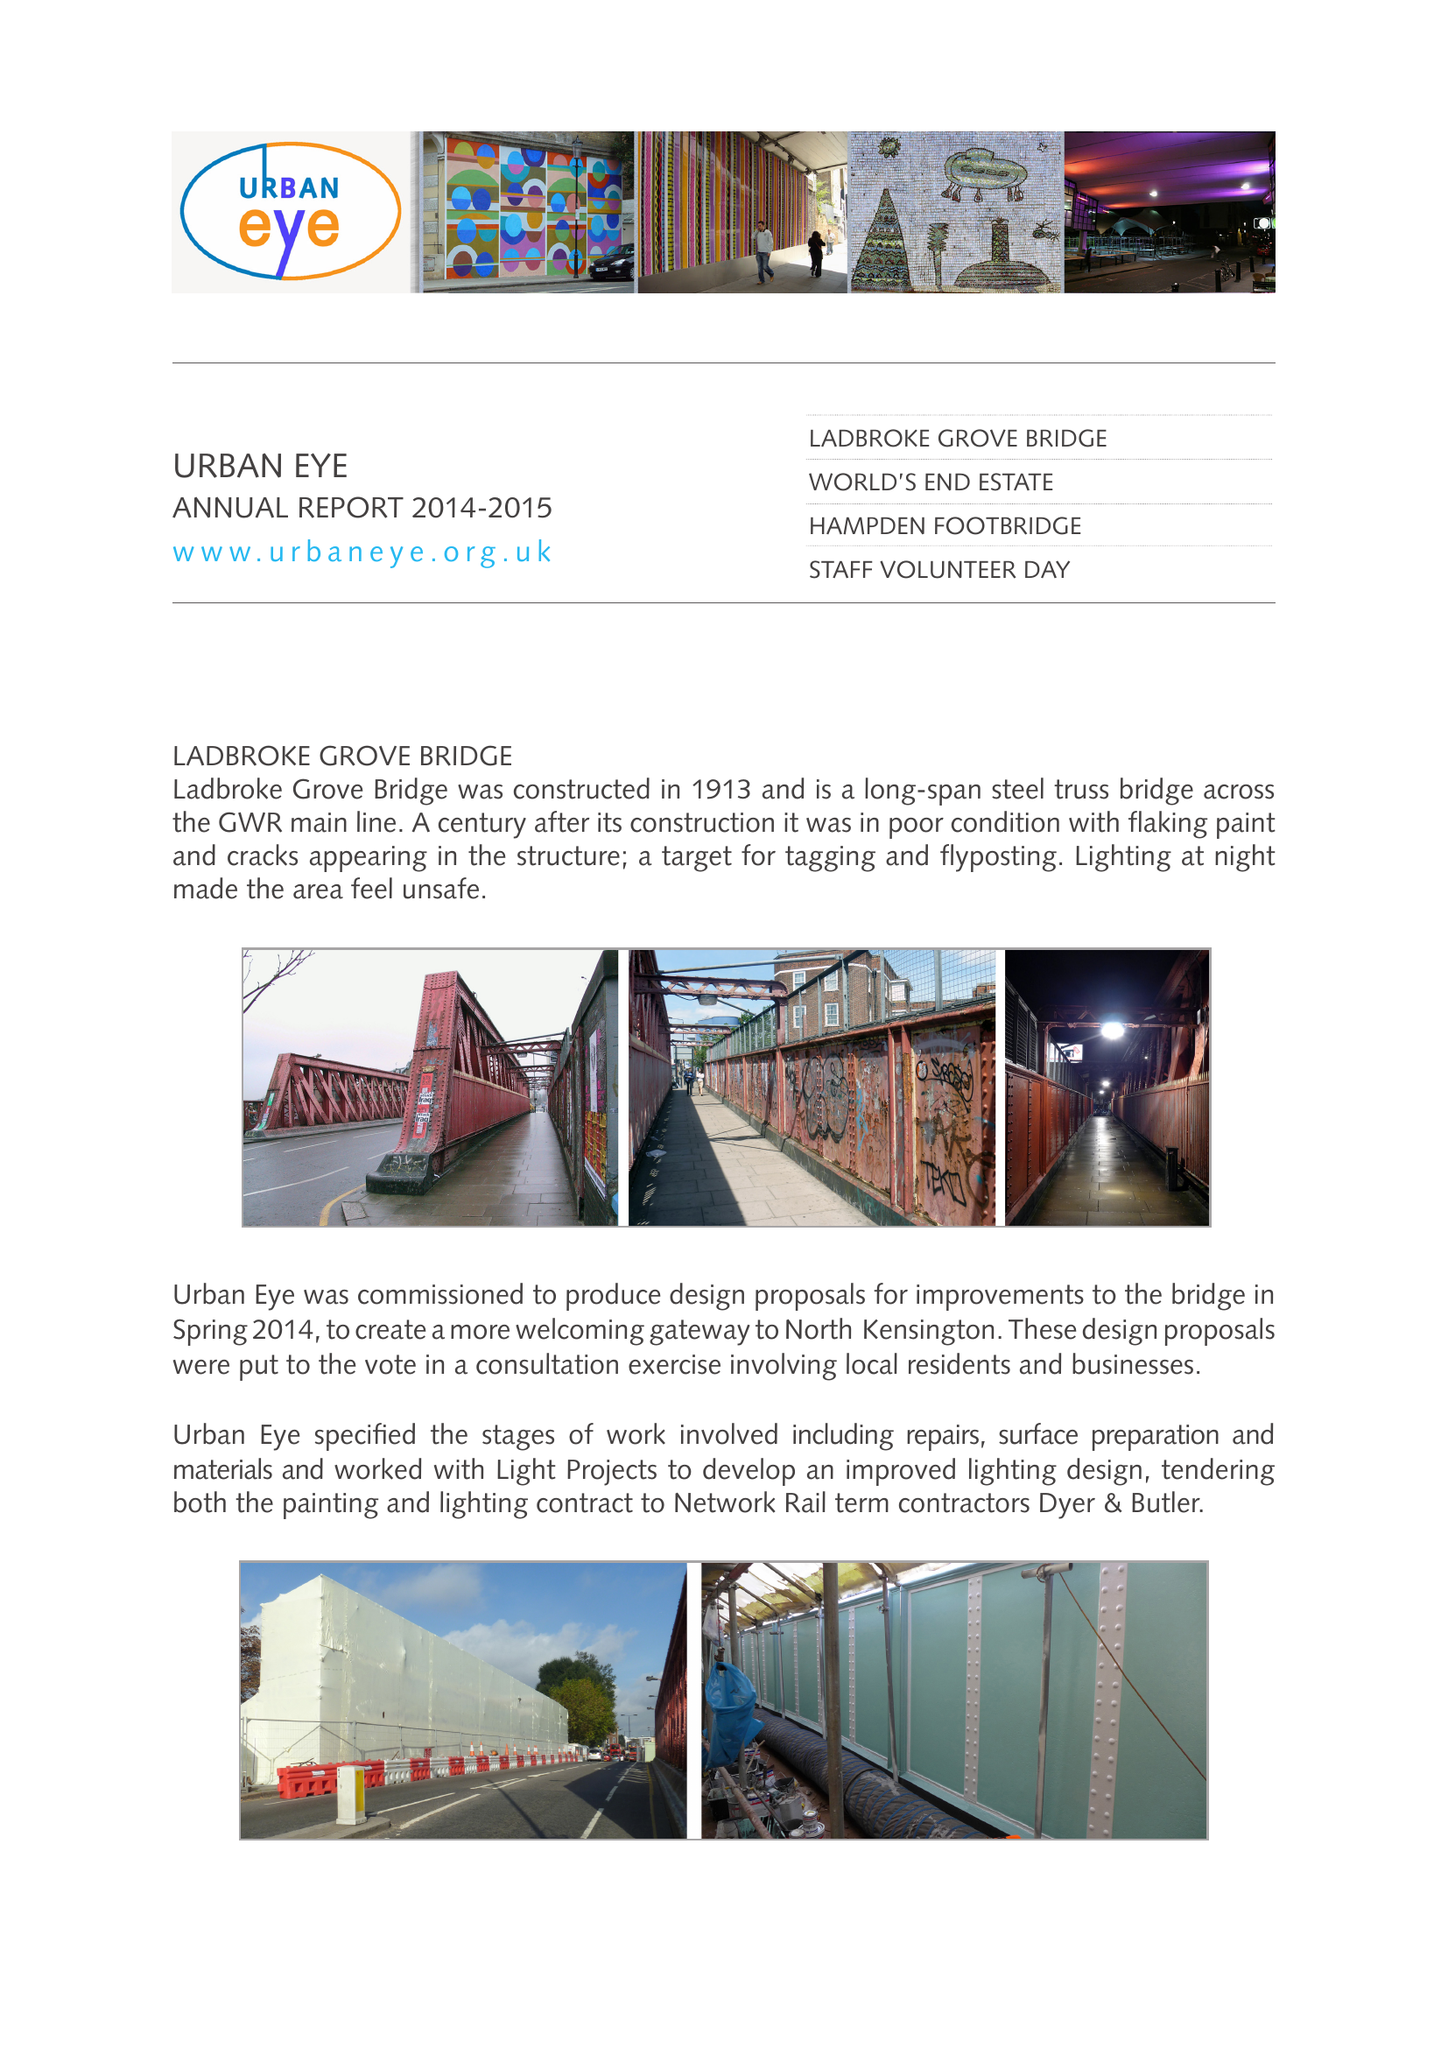What is the value for the charity_name?
Answer the question using a single word or phrase. Urban Eye 